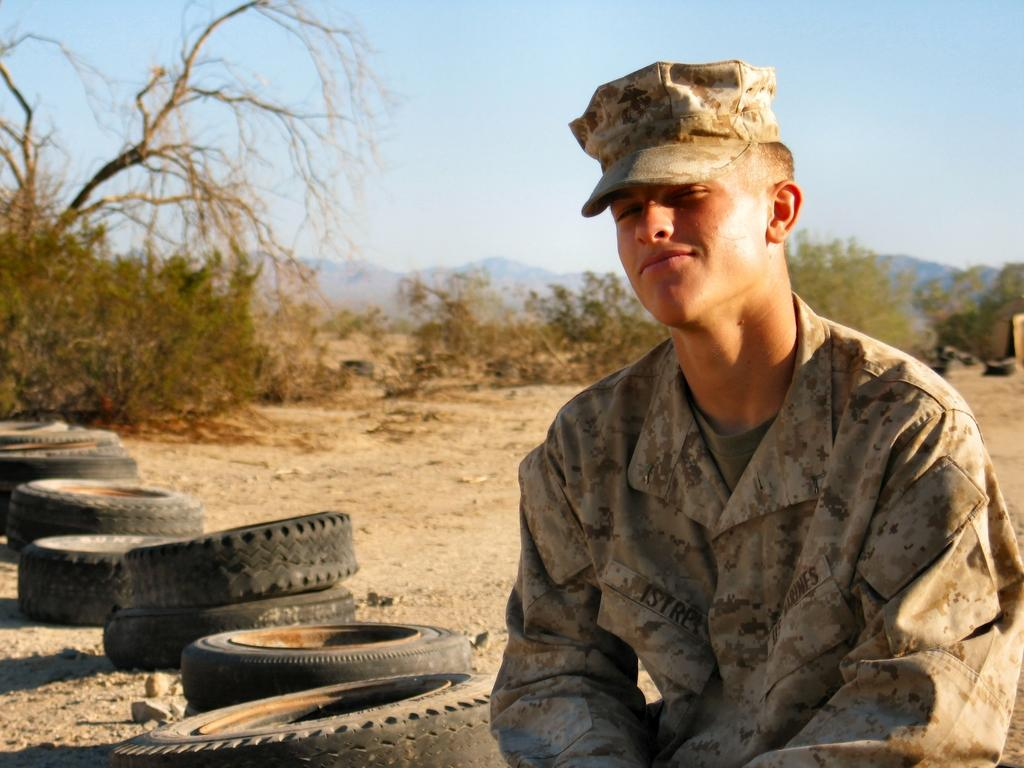What is the main subject of the image? There is a person in the image. What objects are near the person? There are tires beside the person. What type of natural elements can be seen in the image? There are trees and plants in the image. What is visible in the background of the image? The sky and mountains are visible in the image. What type of organization is depicted in the image? There is no organization depicted in the image; it features a person, tires, trees, plants, the sky, and mountains. What kind of mist can be seen surrounding the person in the image? There is no mist present in the image; it is clear and shows the person, tires, trees, plants, the sky, and mountains. 